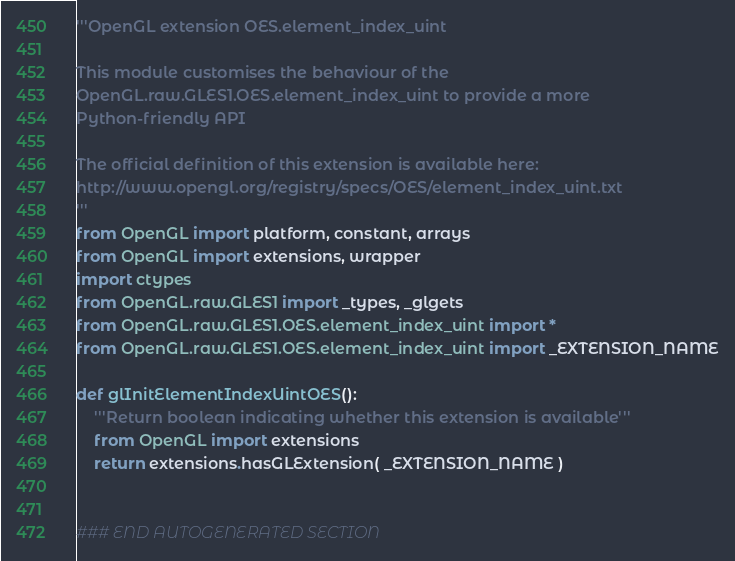Convert code to text. <code><loc_0><loc_0><loc_500><loc_500><_Python_>'''OpenGL extension OES.element_index_uint

This module customises the behaviour of the 
OpenGL.raw.GLES1.OES.element_index_uint to provide a more 
Python-friendly API

The official definition of this extension is available here:
http://www.opengl.org/registry/specs/OES/element_index_uint.txt
'''
from OpenGL import platform, constant, arrays
from OpenGL import extensions, wrapper
import ctypes
from OpenGL.raw.GLES1 import _types, _glgets
from OpenGL.raw.GLES1.OES.element_index_uint import *
from OpenGL.raw.GLES1.OES.element_index_uint import _EXTENSION_NAME

def glInitElementIndexUintOES():
    '''Return boolean indicating whether this extension is available'''
    from OpenGL import extensions
    return extensions.hasGLExtension( _EXTENSION_NAME )


### END AUTOGENERATED SECTION</code> 